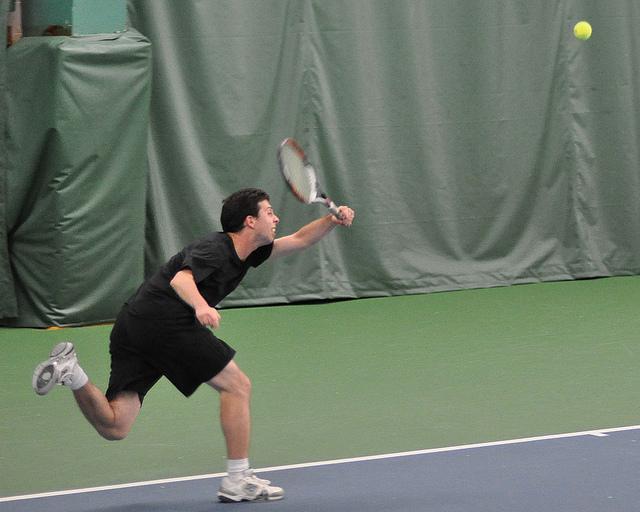Does this man look like a pro?
Concise answer only. No. Is there a tennis ball on the ground?
Short answer required. No. Is this man preparing to hit the tennis ball?
Quick response, please. Yes. Is this man playing opposite to a female?
Keep it brief. No. Is the man going to be able to hit the ball?
Concise answer only. No. 